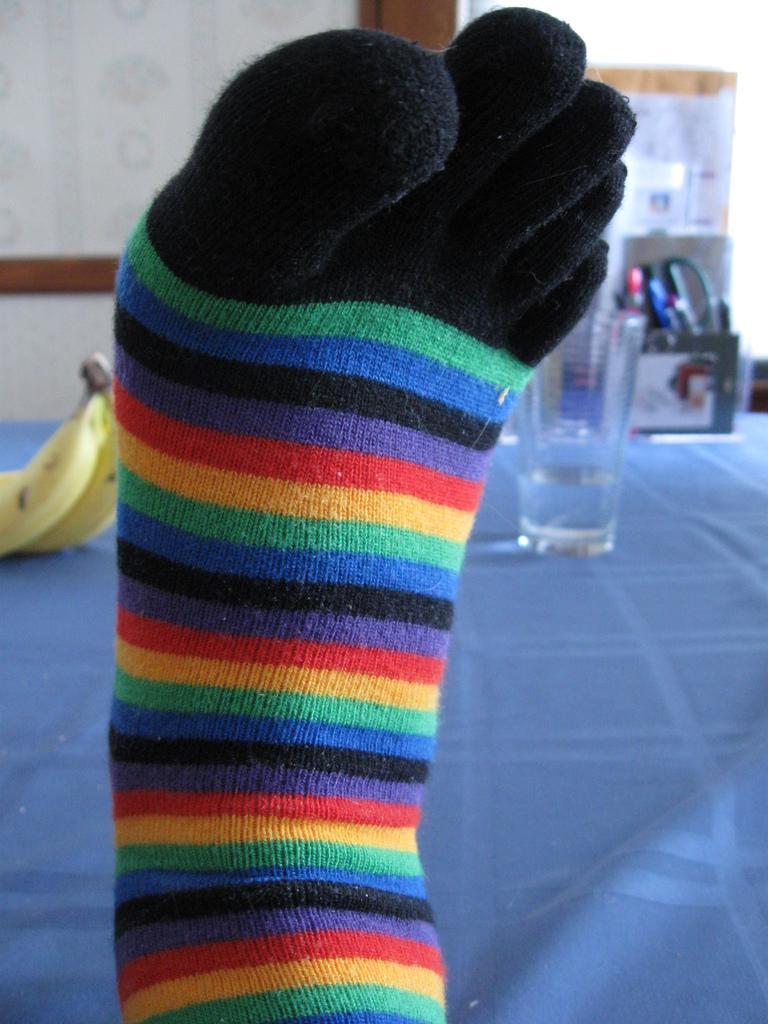How would you summarize this image in a sentence or two? In this image I see a sock which is colorful and I see a glass over here and I see 2 bananas and I see the blue color cloth. In the background I see few things over here and I see the wall. 